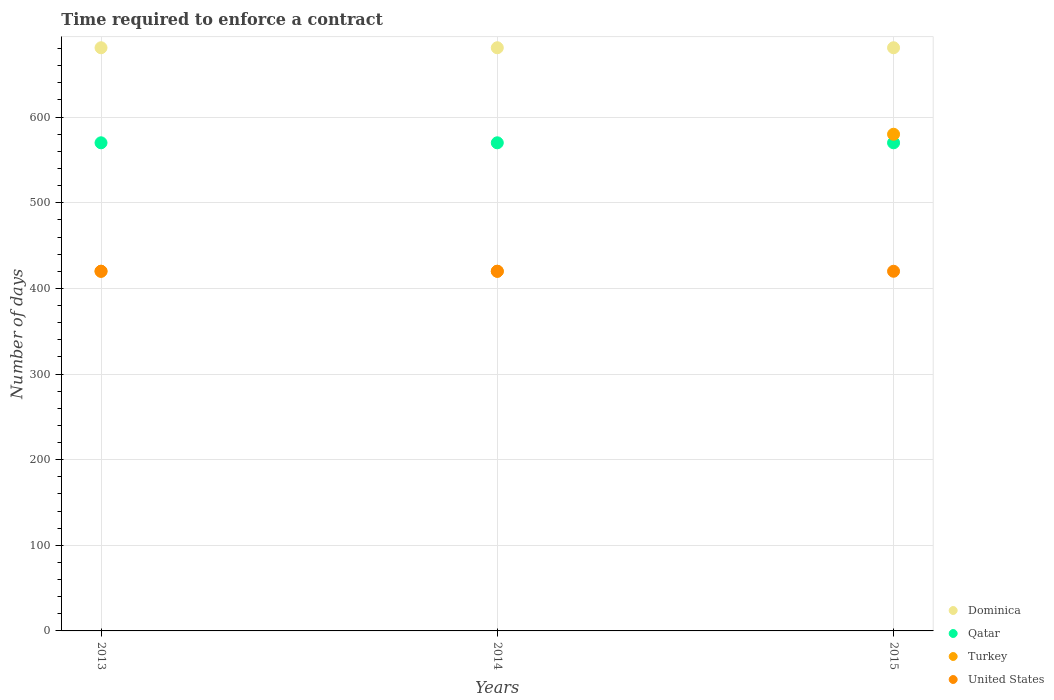What is the number of days required to enforce a contract in Dominica in 2013?
Make the answer very short. 681. Across all years, what is the maximum number of days required to enforce a contract in United States?
Offer a terse response. 420. Across all years, what is the minimum number of days required to enforce a contract in Turkey?
Ensure brevity in your answer.  420. What is the total number of days required to enforce a contract in Turkey in the graph?
Your answer should be very brief. 1420. What is the difference between the number of days required to enforce a contract in Qatar in 2014 and that in 2015?
Keep it short and to the point. 0. What is the difference between the number of days required to enforce a contract in Dominica in 2015 and the number of days required to enforce a contract in United States in 2013?
Make the answer very short. 261. What is the average number of days required to enforce a contract in Qatar per year?
Offer a terse response. 570. In the year 2014, what is the difference between the number of days required to enforce a contract in Qatar and number of days required to enforce a contract in Dominica?
Offer a very short reply. -111. In how many years, is the number of days required to enforce a contract in United States greater than 640 days?
Ensure brevity in your answer.  0. Is the number of days required to enforce a contract in Dominica in 2014 less than that in 2015?
Give a very brief answer. No. Is the difference between the number of days required to enforce a contract in Qatar in 2013 and 2015 greater than the difference between the number of days required to enforce a contract in Dominica in 2013 and 2015?
Offer a terse response. No. What is the difference between the highest and the second highest number of days required to enforce a contract in Turkey?
Give a very brief answer. 160. What is the difference between the highest and the lowest number of days required to enforce a contract in Turkey?
Your response must be concise. 160. In how many years, is the number of days required to enforce a contract in Dominica greater than the average number of days required to enforce a contract in Dominica taken over all years?
Your answer should be very brief. 0. Is it the case that in every year, the sum of the number of days required to enforce a contract in Dominica and number of days required to enforce a contract in Qatar  is greater than the number of days required to enforce a contract in Turkey?
Make the answer very short. Yes. Does the number of days required to enforce a contract in Turkey monotonically increase over the years?
Your response must be concise. No. How many years are there in the graph?
Offer a very short reply. 3. Are the values on the major ticks of Y-axis written in scientific E-notation?
Offer a very short reply. No. How are the legend labels stacked?
Keep it short and to the point. Vertical. What is the title of the graph?
Your answer should be very brief. Time required to enforce a contract. Does "Italy" appear as one of the legend labels in the graph?
Provide a short and direct response. No. What is the label or title of the Y-axis?
Offer a very short reply. Number of days. What is the Number of days in Dominica in 2013?
Provide a short and direct response. 681. What is the Number of days in Qatar in 2013?
Offer a terse response. 570. What is the Number of days in Turkey in 2013?
Offer a terse response. 420. What is the Number of days in United States in 2013?
Make the answer very short. 420. What is the Number of days of Dominica in 2014?
Keep it short and to the point. 681. What is the Number of days of Qatar in 2014?
Ensure brevity in your answer.  570. What is the Number of days of Turkey in 2014?
Your answer should be very brief. 420. What is the Number of days of United States in 2014?
Provide a short and direct response. 420. What is the Number of days in Dominica in 2015?
Provide a succinct answer. 681. What is the Number of days in Qatar in 2015?
Your response must be concise. 570. What is the Number of days of Turkey in 2015?
Ensure brevity in your answer.  580. What is the Number of days of United States in 2015?
Offer a terse response. 420. Across all years, what is the maximum Number of days in Dominica?
Ensure brevity in your answer.  681. Across all years, what is the maximum Number of days of Qatar?
Your answer should be compact. 570. Across all years, what is the maximum Number of days of Turkey?
Your answer should be very brief. 580. Across all years, what is the maximum Number of days of United States?
Your answer should be compact. 420. Across all years, what is the minimum Number of days of Dominica?
Provide a succinct answer. 681. Across all years, what is the minimum Number of days in Qatar?
Keep it short and to the point. 570. Across all years, what is the minimum Number of days in Turkey?
Offer a terse response. 420. Across all years, what is the minimum Number of days of United States?
Make the answer very short. 420. What is the total Number of days in Dominica in the graph?
Your answer should be compact. 2043. What is the total Number of days in Qatar in the graph?
Your answer should be compact. 1710. What is the total Number of days of Turkey in the graph?
Offer a terse response. 1420. What is the total Number of days in United States in the graph?
Ensure brevity in your answer.  1260. What is the difference between the Number of days of Turkey in 2013 and that in 2014?
Ensure brevity in your answer.  0. What is the difference between the Number of days in Turkey in 2013 and that in 2015?
Your answer should be very brief. -160. What is the difference between the Number of days of Dominica in 2014 and that in 2015?
Provide a short and direct response. 0. What is the difference between the Number of days in Turkey in 2014 and that in 2015?
Keep it short and to the point. -160. What is the difference between the Number of days in United States in 2014 and that in 2015?
Provide a succinct answer. 0. What is the difference between the Number of days of Dominica in 2013 and the Number of days of Qatar in 2014?
Your response must be concise. 111. What is the difference between the Number of days of Dominica in 2013 and the Number of days of Turkey in 2014?
Ensure brevity in your answer.  261. What is the difference between the Number of days in Dominica in 2013 and the Number of days in United States in 2014?
Make the answer very short. 261. What is the difference between the Number of days in Qatar in 2013 and the Number of days in Turkey in 2014?
Offer a terse response. 150. What is the difference between the Number of days in Qatar in 2013 and the Number of days in United States in 2014?
Give a very brief answer. 150. What is the difference between the Number of days in Turkey in 2013 and the Number of days in United States in 2014?
Your response must be concise. 0. What is the difference between the Number of days in Dominica in 2013 and the Number of days in Qatar in 2015?
Give a very brief answer. 111. What is the difference between the Number of days in Dominica in 2013 and the Number of days in Turkey in 2015?
Ensure brevity in your answer.  101. What is the difference between the Number of days in Dominica in 2013 and the Number of days in United States in 2015?
Ensure brevity in your answer.  261. What is the difference between the Number of days in Qatar in 2013 and the Number of days in Turkey in 2015?
Keep it short and to the point. -10. What is the difference between the Number of days in Qatar in 2013 and the Number of days in United States in 2015?
Your answer should be compact. 150. What is the difference between the Number of days in Dominica in 2014 and the Number of days in Qatar in 2015?
Ensure brevity in your answer.  111. What is the difference between the Number of days in Dominica in 2014 and the Number of days in Turkey in 2015?
Offer a terse response. 101. What is the difference between the Number of days of Dominica in 2014 and the Number of days of United States in 2015?
Provide a succinct answer. 261. What is the difference between the Number of days of Qatar in 2014 and the Number of days of Turkey in 2015?
Offer a very short reply. -10. What is the difference between the Number of days in Qatar in 2014 and the Number of days in United States in 2015?
Give a very brief answer. 150. What is the difference between the Number of days in Turkey in 2014 and the Number of days in United States in 2015?
Offer a terse response. 0. What is the average Number of days in Dominica per year?
Give a very brief answer. 681. What is the average Number of days of Qatar per year?
Keep it short and to the point. 570. What is the average Number of days of Turkey per year?
Keep it short and to the point. 473.33. What is the average Number of days in United States per year?
Provide a short and direct response. 420. In the year 2013, what is the difference between the Number of days in Dominica and Number of days in Qatar?
Ensure brevity in your answer.  111. In the year 2013, what is the difference between the Number of days in Dominica and Number of days in Turkey?
Provide a short and direct response. 261. In the year 2013, what is the difference between the Number of days in Dominica and Number of days in United States?
Offer a very short reply. 261. In the year 2013, what is the difference between the Number of days of Qatar and Number of days of Turkey?
Give a very brief answer. 150. In the year 2013, what is the difference between the Number of days of Qatar and Number of days of United States?
Provide a short and direct response. 150. In the year 2014, what is the difference between the Number of days in Dominica and Number of days in Qatar?
Ensure brevity in your answer.  111. In the year 2014, what is the difference between the Number of days in Dominica and Number of days in Turkey?
Your response must be concise. 261. In the year 2014, what is the difference between the Number of days of Dominica and Number of days of United States?
Your answer should be compact. 261. In the year 2014, what is the difference between the Number of days of Qatar and Number of days of Turkey?
Provide a succinct answer. 150. In the year 2014, what is the difference between the Number of days of Qatar and Number of days of United States?
Your response must be concise. 150. In the year 2014, what is the difference between the Number of days in Turkey and Number of days in United States?
Give a very brief answer. 0. In the year 2015, what is the difference between the Number of days in Dominica and Number of days in Qatar?
Provide a short and direct response. 111. In the year 2015, what is the difference between the Number of days of Dominica and Number of days of Turkey?
Make the answer very short. 101. In the year 2015, what is the difference between the Number of days in Dominica and Number of days in United States?
Provide a succinct answer. 261. In the year 2015, what is the difference between the Number of days of Qatar and Number of days of Turkey?
Your response must be concise. -10. In the year 2015, what is the difference between the Number of days of Qatar and Number of days of United States?
Offer a terse response. 150. In the year 2015, what is the difference between the Number of days of Turkey and Number of days of United States?
Provide a succinct answer. 160. What is the ratio of the Number of days of Qatar in 2013 to that in 2014?
Give a very brief answer. 1. What is the ratio of the Number of days of Turkey in 2013 to that in 2015?
Your answer should be compact. 0.72. What is the ratio of the Number of days of United States in 2013 to that in 2015?
Keep it short and to the point. 1. What is the ratio of the Number of days of Dominica in 2014 to that in 2015?
Ensure brevity in your answer.  1. What is the ratio of the Number of days of Qatar in 2014 to that in 2015?
Your answer should be very brief. 1. What is the ratio of the Number of days of Turkey in 2014 to that in 2015?
Your response must be concise. 0.72. What is the ratio of the Number of days in United States in 2014 to that in 2015?
Make the answer very short. 1. What is the difference between the highest and the second highest Number of days of Dominica?
Make the answer very short. 0. What is the difference between the highest and the second highest Number of days of Turkey?
Provide a succinct answer. 160. What is the difference between the highest and the lowest Number of days in Turkey?
Your answer should be compact. 160. What is the difference between the highest and the lowest Number of days in United States?
Make the answer very short. 0. 